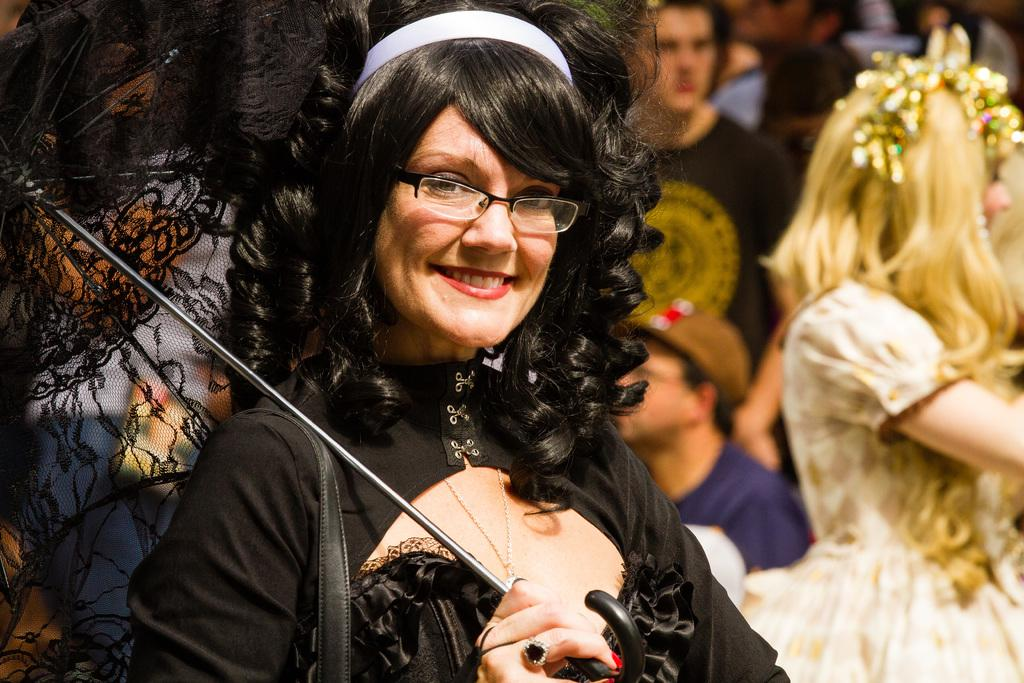Who can be seen in the image? There are people in the image. Can you describe the woman in the image? The woman is wearing a black dress, spectacles, and is holding an umbrella. What is the woman's facial expression in the image? The woman is smiling. How many boys are present in the image? The provided facts do not mention any boys in the image. --- Facts: 1. There is a car in the image. 2. The car is red. 3. The car has four wheels. 4. The car has a license plate. 5. The car is parked on the street. Absurd Topics: bird, ocean, mountain Conversation: What is the main subject of the image? The main subject of the image is a car. Can you describe the car's appearance? The car is red and has four wheels. What is attached to the car for identification purposes? The car has a license plate. Where is the car located in the image? The car is parked on the street. Reasoning: Let's think step by step in order to produce the conversation. We start by identifying the main subject of the image, which is the car. Then, we describe the car's appearance, including its color and number of wheels. Next, we mention the license plate, which is an important detail for identification. Finally, we describe the car's location, which is on the street. Absurd Question/Answer: Can you see any mountains in the background of the image? The provided facts do not mention any mountains in the image. 